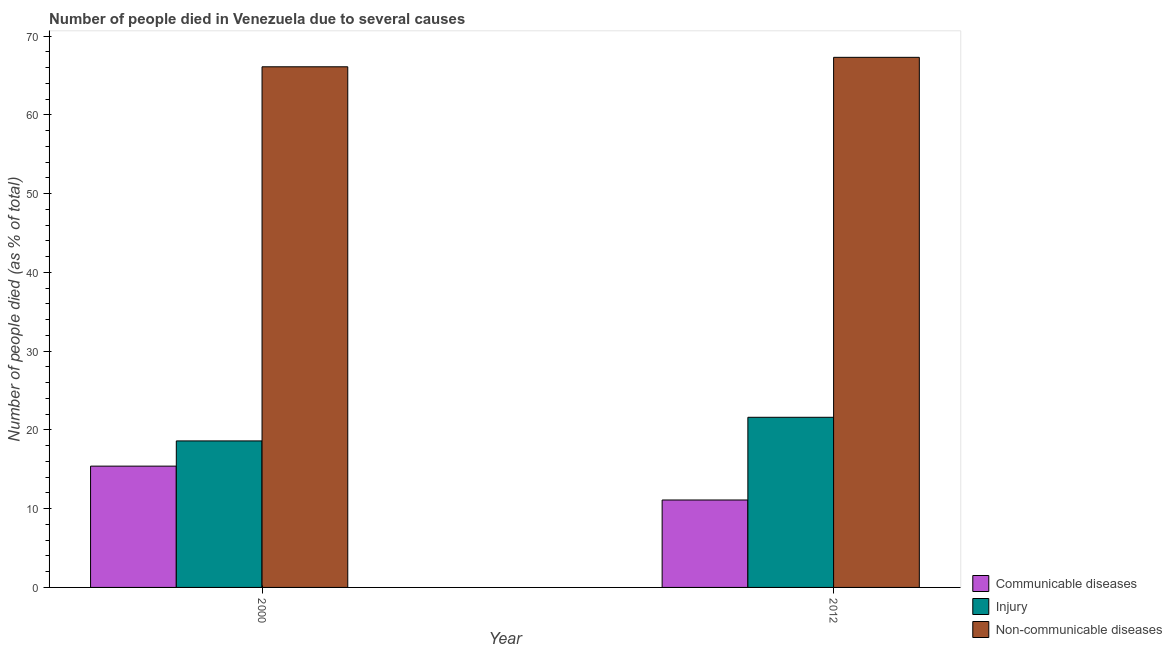Are the number of bars on each tick of the X-axis equal?
Your answer should be very brief. Yes. What is the label of the 1st group of bars from the left?
Ensure brevity in your answer.  2000. Across all years, what is the maximum number of people who dies of non-communicable diseases?
Ensure brevity in your answer.  67.3. Across all years, what is the minimum number of people who died of communicable diseases?
Make the answer very short. 11.1. What is the total number of people who died of injury in the graph?
Keep it short and to the point. 40.2. What is the difference between the number of people who died of injury in 2000 and that in 2012?
Your answer should be compact. -3. What is the difference between the number of people who dies of non-communicable diseases in 2000 and the number of people who died of injury in 2012?
Your response must be concise. -1.2. What is the average number of people who died of injury per year?
Offer a very short reply. 20.1. In the year 2012, what is the difference between the number of people who died of injury and number of people who died of communicable diseases?
Keep it short and to the point. 0. What is the ratio of the number of people who died of injury in 2000 to that in 2012?
Give a very brief answer. 0.86. What does the 3rd bar from the left in 2000 represents?
Ensure brevity in your answer.  Non-communicable diseases. What does the 1st bar from the right in 2000 represents?
Ensure brevity in your answer.  Non-communicable diseases. Is it the case that in every year, the sum of the number of people who died of communicable diseases and number of people who died of injury is greater than the number of people who dies of non-communicable diseases?
Make the answer very short. No. How many years are there in the graph?
Keep it short and to the point. 2. What is the difference between two consecutive major ticks on the Y-axis?
Your answer should be very brief. 10. Does the graph contain any zero values?
Make the answer very short. No. Where does the legend appear in the graph?
Give a very brief answer. Bottom right. What is the title of the graph?
Give a very brief answer. Number of people died in Venezuela due to several causes. What is the label or title of the Y-axis?
Offer a very short reply. Number of people died (as % of total). What is the Number of people died (as % of total) of Communicable diseases in 2000?
Keep it short and to the point. 15.4. What is the Number of people died (as % of total) of Non-communicable diseases in 2000?
Your response must be concise. 66.1. What is the Number of people died (as % of total) in Injury in 2012?
Keep it short and to the point. 21.6. What is the Number of people died (as % of total) in Non-communicable diseases in 2012?
Ensure brevity in your answer.  67.3. Across all years, what is the maximum Number of people died (as % of total) of Communicable diseases?
Your answer should be compact. 15.4. Across all years, what is the maximum Number of people died (as % of total) in Injury?
Make the answer very short. 21.6. Across all years, what is the maximum Number of people died (as % of total) in Non-communicable diseases?
Keep it short and to the point. 67.3. Across all years, what is the minimum Number of people died (as % of total) in Communicable diseases?
Your answer should be compact. 11.1. Across all years, what is the minimum Number of people died (as % of total) in Injury?
Ensure brevity in your answer.  18.6. Across all years, what is the minimum Number of people died (as % of total) of Non-communicable diseases?
Offer a very short reply. 66.1. What is the total Number of people died (as % of total) of Injury in the graph?
Keep it short and to the point. 40.2. What is the total Number of people died (as % of total) in Non-communicable diseases in the graph?
Keep it short and to the point. 133.4. What is the difference between the Number of people died (as % of total) in Injury in 2000 and that in 2012?
Make the answer very short. -3. What is the difference between the Number of people died (as % of total) of Non-communicable diseases in 2000 and that in 2012?
Provide a short and direct response. -1.2. What is the difference between the Number of people died (as % of total) of Communicable diseases in 2000 and the Number of people died (as % of total) of Non-communicable diseases in 2012?
Your answer should be very brief. -51.9. What is the difference between the Number of people died (as % of total) in Injury in 2000 and the Number of people died (as % of total) in Non-communicable diseases in 2012?
Offer a terse response. -48.7. What is the average Number of people died (as % of total) of Communicable diseases per year?
Your response must be concise. 13.25. What is the average Number of people died (as % of total) in Injury per year?
Provide a succinct answer. 20.1. What is the average Number of people died (as % of total) in Non-communicable diseases per year?
Your answer should be compact. 66.7. In the year 2000, what is the difference between the Number of people died (as % of total) of Communicable diseases and Number of people died (as % of total) of Non-communicable diseases?
Give a very brief answer. -50.7. In the year 2000, what is the difference between the Number of people died (as % of total) in Injury and Number of people died (as % of total) in Non-communicable diseases?
Make the answer very short. -47.5. In the year 2012, what is the difference between the Number of people died (as % of total) of Communicable diseases and Number of people died (as % of total) of Non-communicable diseases?
Provide a short and direct response. -56.2. In the year 2012, what is the difference between the Number of people died (as % of total) of Injury and Number of people died (as % of total) of Non-communicable diseases?
Offer a terse response. -45.7. What is the ratio of the Number of people died (as % of total) of Communicable diseases in 2000 to that in 2012?
Offer a very short reply. 1.39. What is the ratio of the Number of people died (as % of total) of Injury in 2000 to that in 2012?
Give a very brief answer. 0.86. What is the ratio of the Number of people died (as % of total) of Non-communicable diseases in 2000 to that in 2012?
Your response must be concise. 0.98. What is the difference between the highest and the second highest Number of people died (as % of total) of Communicable diseases?
Provide a short and direct response. 4.3. What is the difference between the highest and the second highest Number of people died (as % of total) in Non-communicable diseases?
Ensure brevity in your answer.  1.2. What is the difference between the highest and the lowest Number of people died (as % of total) of Communicable diseases?
Make the answer very short. 4.3. 